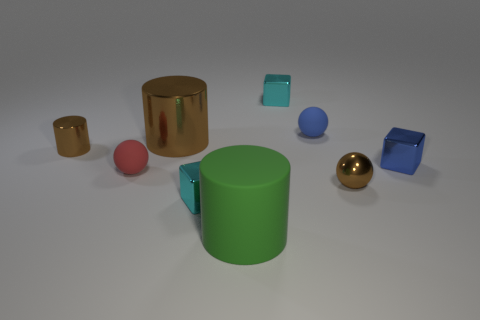How many objects are there in the image, and can you describe their colors? There are seven objects in the image. Starting from the left, there's a small gold cylinder, a metallic brown cylinder, a small teal cube, a larger green cylinder, a blue ball, a reflective gold sphere, and finally, another small teal cube. 